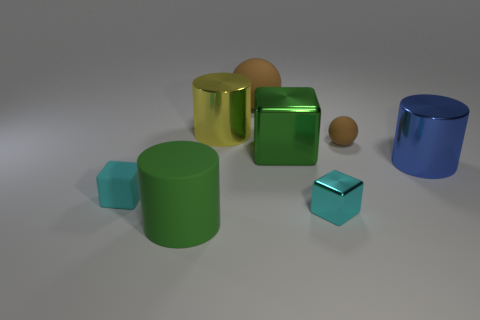There is a big cylinder that is to the right of the small brown ball; is it the same color as the small metallic cube?
Your response must be concise. No. What number of matte objects are either large spheres or blocks?
Give a very brief answer. 2. There is a small cube that is to the left of the shiny cylinder left of the blue cylinder; what is it made of?
Your answer should be very brief. Rubber. What material is the other small cube that is the same color as the tiny rubber block?
Give a very brief answer. Metal. The matte cube is what color?
Ensure brevity in your answer.  Cyan. Are there any large blue metallic cylinders that are behind the large object that is on the right side of the large green shiny cube?
Your answer should be compact. No. What is the material of the large green cube?
Make the answer very short. Metal. Do the small cyan cube left of the cyan shiny object and the brown sphere that is behind the tiny sphere have the same material?
Your answer should be compact. Yes. Is there any other thing that is the same color as the tiny metallic object?
Offer a terse response. Yes. What is the color of the other rubber object that is the same shape as the large brown object?
Provide a succinct answer. Brown. 